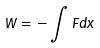<formula> <loc_0><loc_0><loc_500><loc_500>W = - \int F d x</formula> 